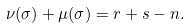<formula> <loc_0><loc_0><loc_500><loc_500>\nu ( \sigma ) + \mu ( \sigma ) = r + s - n .</formula> 